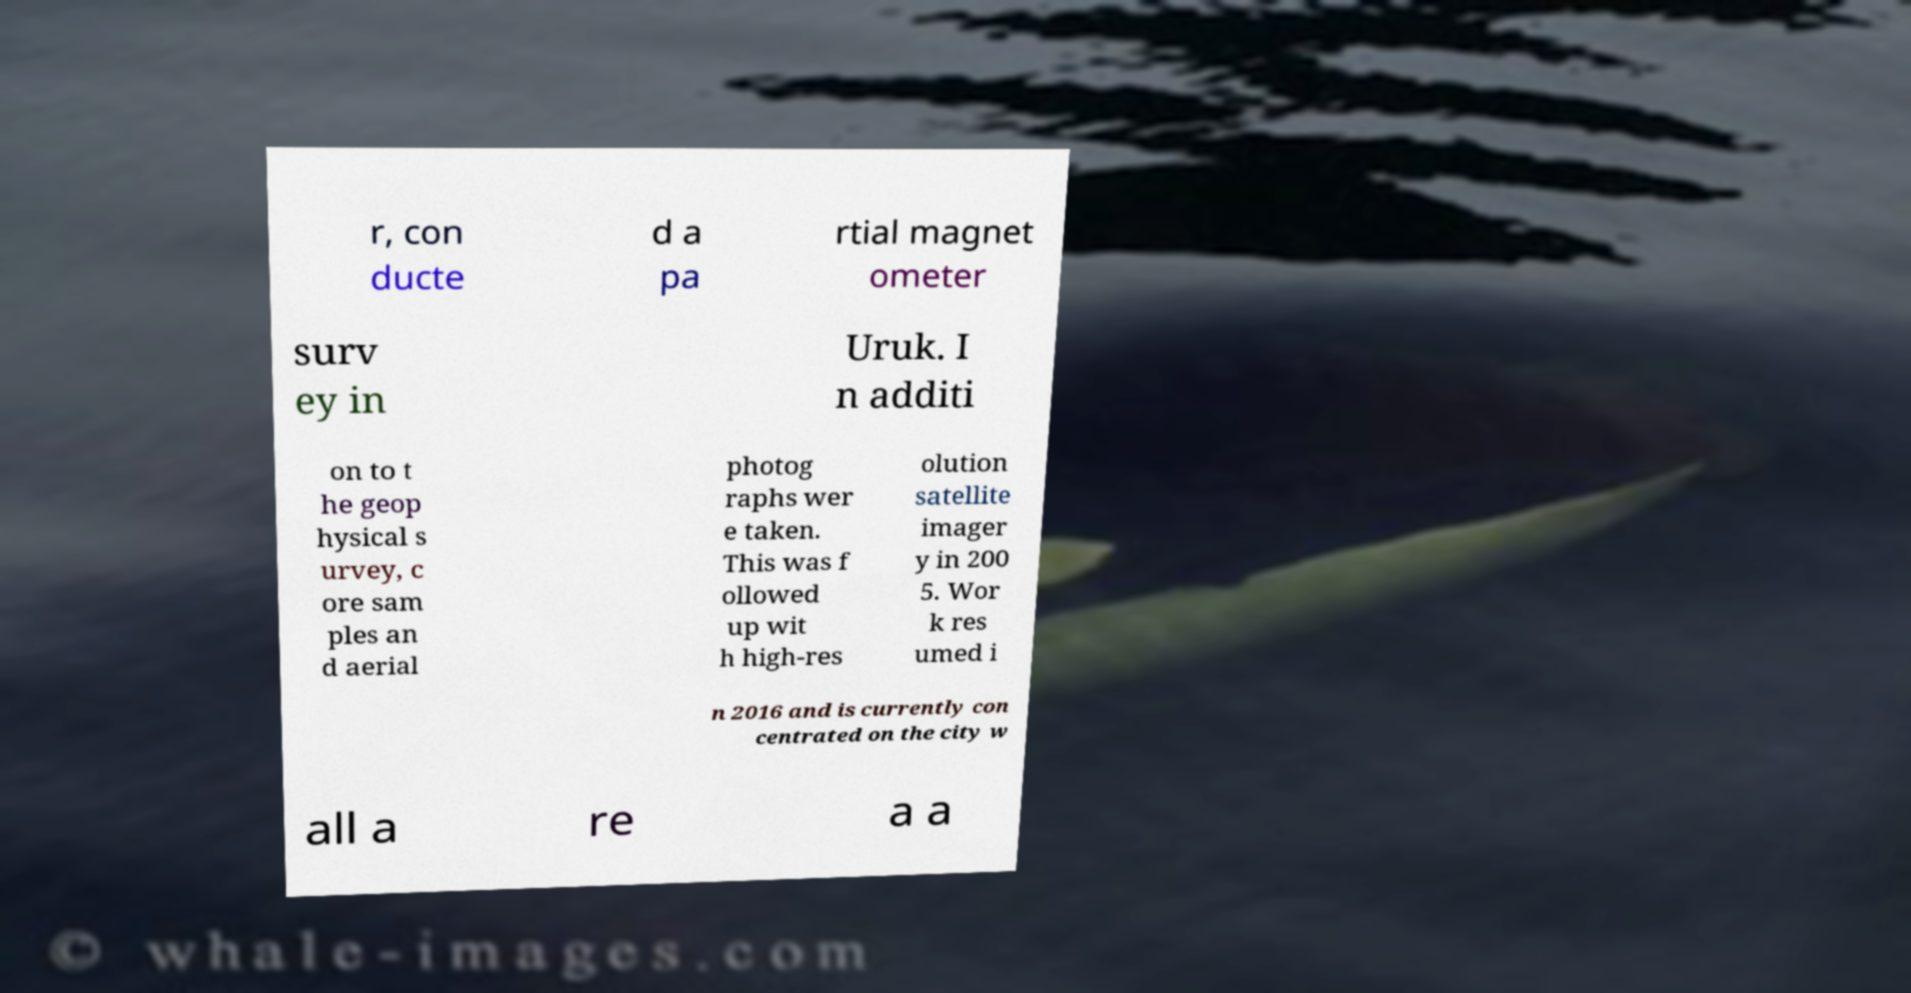There's text embedded in this image that I need extracted. Can you transcribe it verbatim? r, con ducte d a pa rtial magnet ometer surv ey in Uruk. I n additi on to t he geop hysical s urvey, c ore sam ples an d aerial photog raphs wer e taken. This was f ollowed up wit h high-res olution satellite imager y in 200 5. Wor k res umed i n 2016 and is currently con centrated on the city w all a re a a 